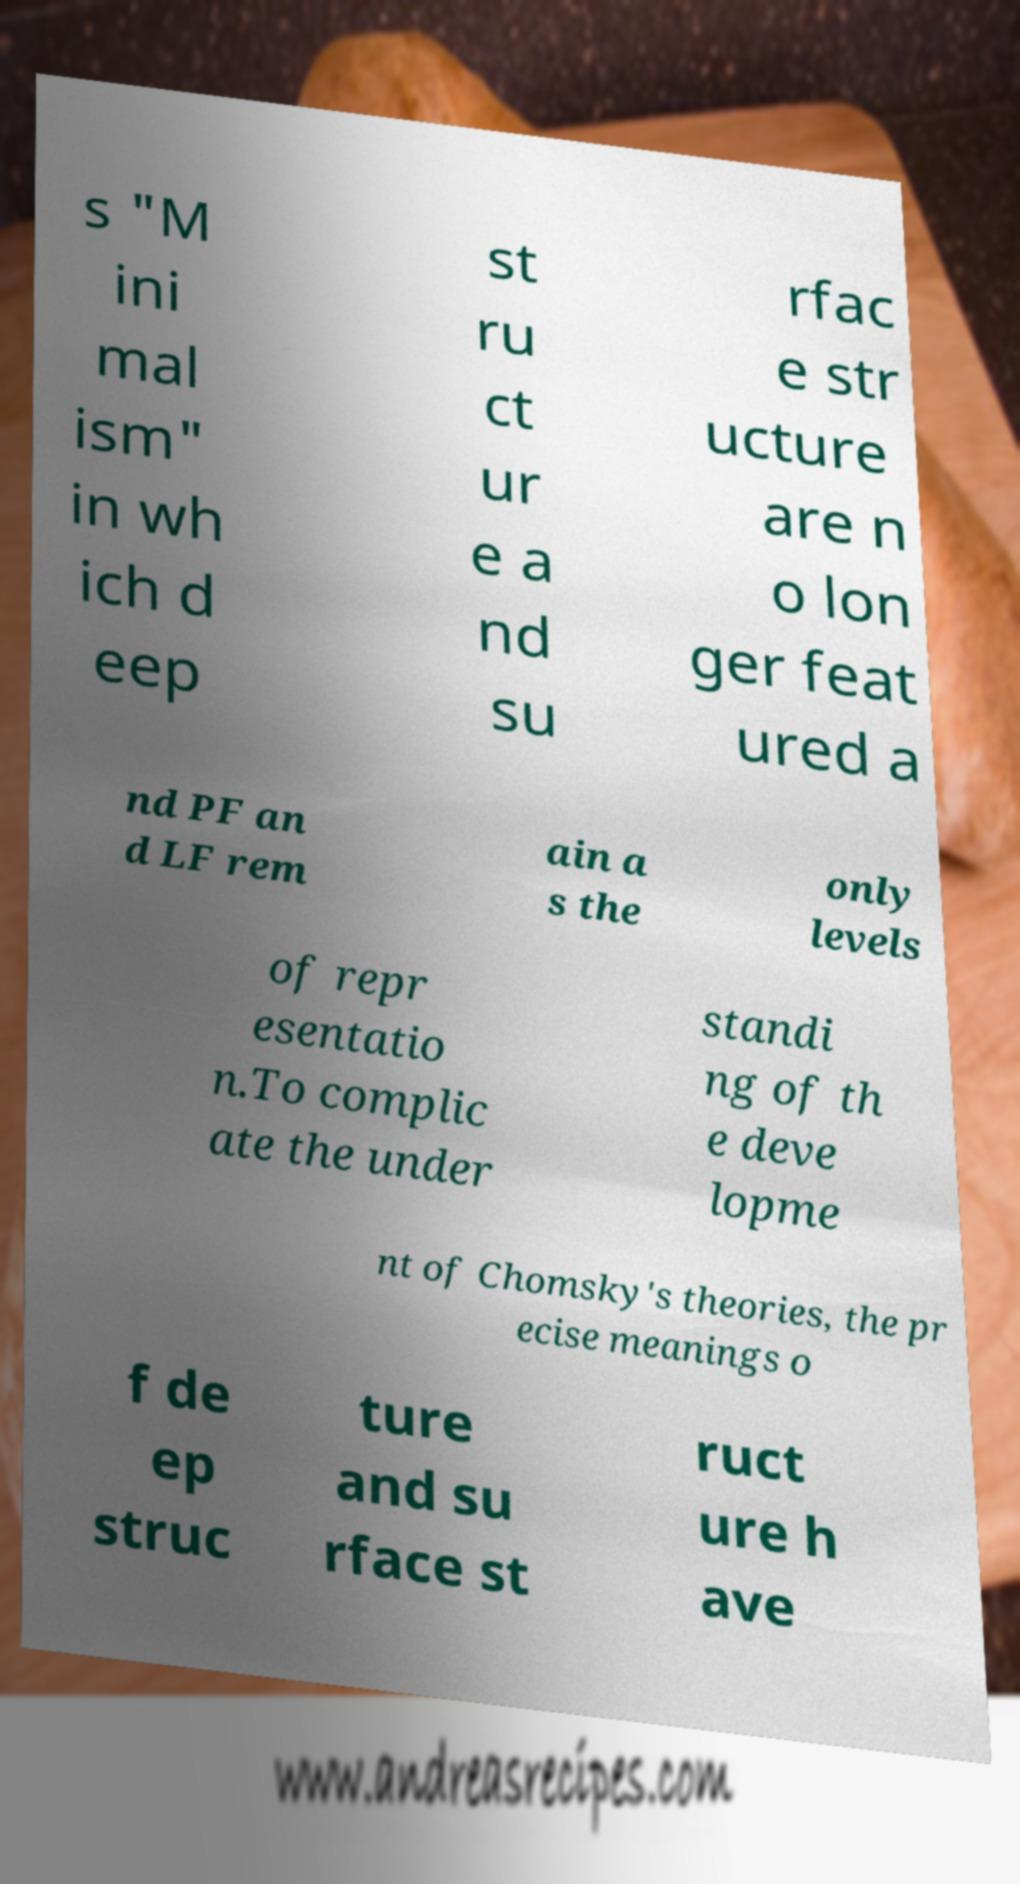Could you assist in decoding the text presented in this image and type it out clearly? s "M ini mal ism" in wh ich d eep st ru ct ur e a nd su rfac e str ucture are n o lon ger feat ured a nd PF an d LF rem ain a s the only levels of repr esentatio n.To complic ate the under standi ng of th e deve lopme nt of Chomsky's theories, the pr ecise meanings o f de ep struc ture and su rface st ruct ure h ave 